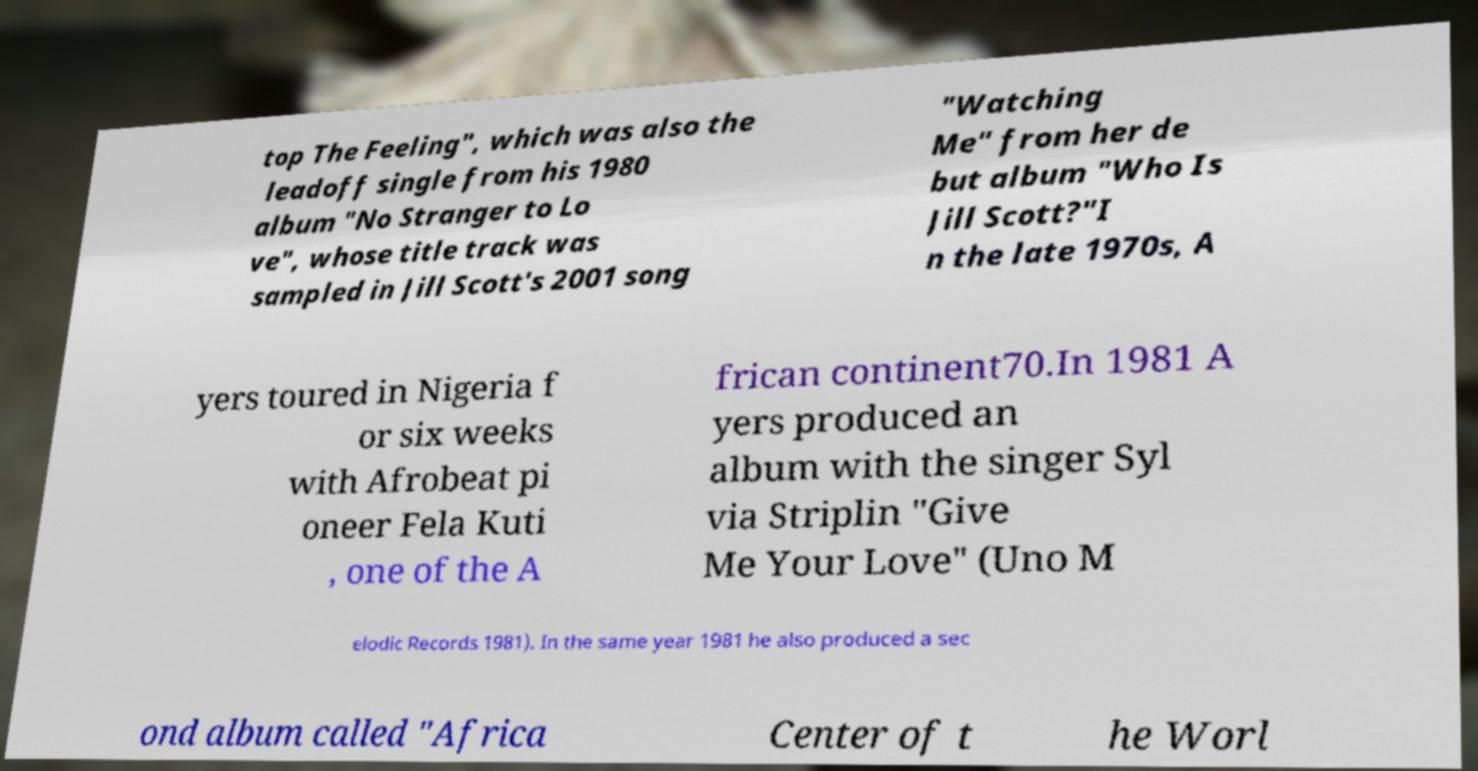There's text embedded in this image that I need extracted. Can you transcribe it verbatim? top The Feeling", which was also the leadoff single from his 1980 album "No Stranger to Lo ve", whose title track was sampled in Jill Scott's 2001 song "Watching Me" from her de but album "Who Is Jill Scott?"I n the late 1970s, A yers toured in Nigeria f or six weeks with Afrobeat pi oneer Fela Kuti , one of the A frican continent70.In 1981 A yers produced an album with the singer Syl via Striplin "Give Me Your Love" (Uno M elodic Records 1981). In the same year 1981 he also produced a sec ond album called "Africa Center of t he Worl 